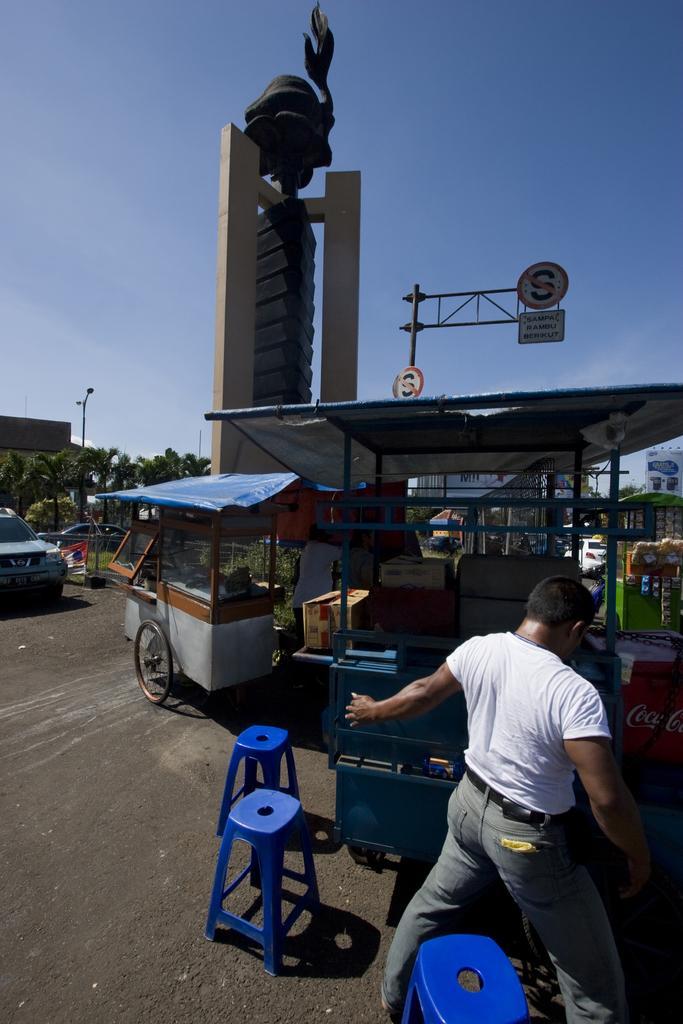Could you give a brief overview of what you see in this image? In this image we can see vehicles, roof, sculpture and boards attached to a pole. In the background, we can see a group of trees and buildings. In the foreground we can a person and chairs. At the top we can see the sky. 